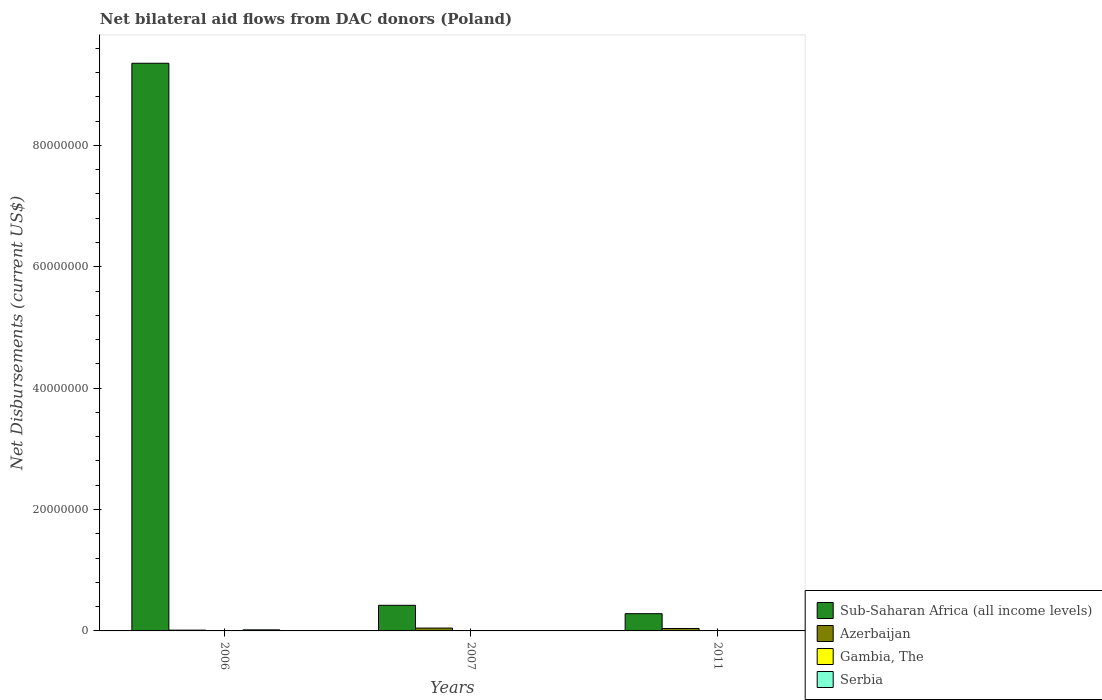How many groups of bars are there?
Your answer should be very brief. 3. How many bars are there on the 3rd tick from the right?
Your answer should be very brief. 4. What is the net bilateral aid flows in Gambia, The in 2007?
Make the answer very short. 2.00e+04. Across all years, what is the maximum net bilateral aid flows in Sub-Saharan Africa (all income levels)?
Keep it short and to the point. 9.35e+07. Across all years, what is the minimum net bilateral aid flows in Gambia, The?
Offer a terse response. 10000. In which year was the net bilateral aid flows in Serbia maximum?
Keep it short and to the point. 2006. What is the difference between the net bilateral aid flows in Gambia, The in 2006 and that in 2011?
Make the answer very short. 2.00e+04. What is the difference between the net bilateral aid flows in Serbia in 2007 and the net bilateral aid flows in Sub-Saharan Africa (all income levels) in 2011?
Your response must be concise. -2.84e+06. What is the average net bilateral aid flows in Sub-Saharan Africa (all income levels) per year?
Your response must be concise. 3.35e+07. In the year 2011, what is the difference between the net bilateral aid flows in Gambia, The and net bilateral aid flows in Sub-Saharan Africa (all income levels)?
Offer a terse response. -2.83e+06. In how many years, is the net bilateral aid flows in Gambia, The greater than 32000000 US$?
Provide a succinct answer. 0. What is the ratio of the net bilateral aid flows in Sub-Saharan Africa (all income levels) in 2006 to that in 2011?
Your answer should be compact. 32.94. What is the difference between the highest and the second highest net bilateral aid flows in Sub-Saharan Africa (all income levels)?
Provide a succinct answer. 8.93e+07. What is the difference between the highest and the lowest net bilateral aid flows in Sub-Saharan Africa (all income levels)?
Offer a terse response. 9.07e+07. Are all the bars in the graph horizontal?
Provide a short and direct response. No. What is the difference between two consecutive major ticks on the Y-axis?
Provide a short and direct response. 2.00e+07. Are the values on the major ticks of Y-axis written in scientific E-notation?
Your response must be concise. No. Does the graph contain any zero values?
Ensure brevity in your answer.  Yes. Where does the legend appear in the graph?
Your response must be concise. Bottom right. How many legend labels are there?
Give a very brief answer. 4. How are the legend labels stacked?
Your answer should be very brief. Vertical. What is the title of the graph?
Your answer should be compact. Net bilateral aid flows from DAC donors (Poland). What is the label or title of the X-axis?
Provide a succinct answer. Years. What is the label or title of the Y-axis?
Offer a very short reply. Net Disbursements (current US$). What is the Net Disbursements (current US$) in Sub-Saharan Africa (all income levels) in 2006?
Your answer should be compact. 9.35e+07. What is the Net Disbursements (current US$) of Azerbaijan in 2006?
Your answer should be compact. 1.30e+05. What is the Net Disbursements (current US$) of Gambia, The in 2006?
Give a very brief answer. 3.00e+04. What is the Net Disbursements (current US$) of Sub-Saharan Africa (all income levels) in 2007?
Keep it short and to the point. 4.22e+06. What is the Net Disbursements (current US$) in Azerbaijan in 2007?
Your response must be concise. 4.70e+05. What is the Net Disbursements (current US$) in Sub-Saharan Africa (all income levels) in 2011?
Your answer should be very brief. 2.84e+06. What is the Net Disbursements (current US$) in Azerbaijan in 2011?
Make the answer very short. 4.00e+05. What is the Net Disbursements (current US$) of Gambia, The in 2011?
Offer a terse response. 10000. What is the Net Disbursements (current US$) in Serbia in 2011?
Provide a short and direct response. 0. Across all years, what is the maximum Net Disbursements (current US$) in Sub-Saharan Africa (all income levels)?
Provide a succinct answer. 9.35e+07. Across all years, what is the maximum Net Disbursements (current US$) in Azerbaijan?
Your answer should be very brief. 4.70e+05. Across all years, what is the maximum Net Disbursements (current US$) in Gambia, The?
Your response must be concise. 3.00e+04. Across all years, what is the maximum Net Disbursements (current US$) in Serbia?
Provide a succinct answer. 1.80e+05. Across all years, what is the minimum Net Disbursements (current US$) in Sub-Saharan Africa (all income levels)?
Ensure brevity in your answer.  2.84e+06. What is the total Net Disbursements (current US$) in Sub-Saharan Africa (all income levels) in the graph?
Ensure brevity in your answer.  1.01e+08. What is the total Net Disbursements (current US$) of Azerbaijan in the graph?
Your answer should be compact. 1.00e+06. What is the total Net Disbursements (current US$) of Gambia, The in the graph?
Provide a succinct answer. 6.00e+04. What is the difference between the Net Disbursements (current US$) of Sub-Saharan Africa (all income levels) in 2006 and that in 2007?
Make the answer very short. 8.93e+07. What is the difference between the Net Disbursements (current US$) of Azerbaijan in 2006 and that in 2007?
Your response must be concise. -3.40e+05. What is the difference between the Net Disbursements (current US$) in Sub-Saharan Africa (all income levels) in 2006 and that in 2011?
Your response must be concise. 9.07e+07. What is the difference between the Net Disbursements (current US$) in Gambia, The in 2006 and that in 2011?
Make the answer very short. 2.00e+04. What is the difference between the Net Disbursements (current US$) in Sub-Saharan Africa (all income levels) in 2007 and that in 2011?
Offer a very short reply. 1.38e+06. What is the difference between the Net Disbursements (current US$) in Sub-Saharan Africa (all income levels) in 2006 and the Net Disbursements (current US$) in Azerbaijan in 2007?
Your answer should be compact. 9.31e+07. What is the difference between the Net Disbursements (current US$) in Sub-Saharan Africa (all income levels) in 2006 and the Net Disbursements (current US$) in Gambia, The in 2007?
Make the answer very short. 9.35e+07. What is the difference between the Net Disbursements (current US$) in Sub-Saharan Africa (all income levels) in 2006 and the Net Disbursements (current US$) in Azerbaijan in 2011?
Offer a very short reply. 9.31e+07. What is the difference between the Net Disbursements (current US$) in Sub-Saharan Africa (all income levels) in 2006 and the Net Disbursements (current US$) in Gambia, The in 2011?
Your answer should be compact. 9.35e+07. What is the difference between the Net Disbursements (current US$) in Sub-Saharan Africa (all income levels) in 2007 and the Net Disbursements (current US$) in Azerbaijan in 2011?
Make the answer very short. 3.82e+06. What is the difference between the Net Disbursements (current US$) in Sub-Saharan Africa (all income levels) in 2007 and the Net Disbursements (current US$) in Gambia, The in 2011?
Provide a short and direct response. 4.21e+06. What is the average Net Disbursements (current US$) in Sub-Saharan Africa (all income levels) per year?
Your answer should be very brief. 3.35e+07. What is the average Net Disbursements (current US$) of Azerbaijan per year?
Offer a very short reply. 3.33e+05. What is the average Net Disbursements (current US$) of Gambia, The per year?
Your response must be concise. 2.00e+04. What is the average Net Disbursements (current US$) of Serbia per year?
Keep it short and to the point. 6.00e+04. In the year 2006, what is the difference between the Net Disbursements (current US$) of Sub-Saharan Africa (all income levels) and Net Disbursements (current US$) of Azerbaijan?
Make the answer very short. 9.34e+07. In the year 2006, what is the difference between the Net Disbursements (current US$) of Sub-Saharan Africa (all income levels) and Net Disbursements (current US$) of Gambia, The?
Give a very brief answer. 9.35e+07. In the year 2006, what is the difference between the Net Disbursements (current US$) of Sub-Saharan Africa (all income levels) and Net Disbursements (current US$) of Serbia?
Your response must be concise. 9.34e+07. In the year 2006, what is the difference between the Net Disbursements (current US$) in Azerbaijan and Net Disbursements (current US$) in Gambia, The?
Offer a very short reply. 1.00e+05. In the year 2006, what is the difference between the Net Disbursements (current US$) of Azerbaijan and Net Disbursements (current US$) of Serbia?
Offer a terse response. -5.00e+04. In the year 2007, what is the difference between the Net Disbursements (current US$) of Sub-Saharan Africa (all income levels) and Net Disbursements (current US$) of Azerbaijan?
Keep it short and to the point. 3.75e+06. In the year 2007, what is the difference between the Net Disbursements (current US$) in Sub-Saharan Africa (all income levels) and Net Disbursements (current US$) in Gambia, The?
Your answer should be compact. 4.20e+06. In the year 2007, what is the difference between the Net Disbursements (current US$) in Azerbaijan and Net Disbursements (current US$) in Gambia, The?
Give a very brief answer. 4.50e+05. In the year 2011, what is the difference between the Net Disbursements (current US$) in Sub-Saharan Africa (all income levels) and Net Disbursements (current US$) in Azerbaijan?
Keep it short and to the point. 2.44e+06. In the year 2011, what is the difference between the Net Disbursements (current US$) of Sub-Saharan Africa (all income levels) and Net Disbursements (current US$) of Gambia, The?
Provide a succinct answer. 2.83e+06. In the year 2011, what is the difference between the Net Disbursements (current US$) of Azerbaijan and Net Disbursements (current US$) of Gambia, The?
Your answer should be compact. 3.90e+05. What is the ratio of the Net Disbursements (current US$) in Sub-Saharan Africa (all income levels) in 2006 to that in 2007?
Your answer should be compact. 22.17. What is the ratio of the Net Disbursements (current US$) of Azerbaijan in 2006 to that in 2007?
Provide a short and direct response. 0.28. What is the ratio of the Net Disbursements (current US$) of Gambia, The in 2006 to that in 2007?
Your answer should be very brief. 1.5. What is the ratio of the Net Disbursements (current US$) in Sub-Saharan Africa (all income levels) in 2006 to that in 2011?
Your response must be concise. 32.94. What is the ratio of the Net Disbursements (current US$) of Azerbaijan in 2006 to that in 2011?
Make the answer very short. 0.33. What is the ratio of the Net Disbursements (current US$) in Gambia, The in 2006 to that in 2011?
Provide a short and direct response. 3. What is the ratio of the Net Disbursements (current US$) in Sub-Saharan Africa (all income levels) in 2007 to that in 2011?
Make the answer very short. 1.49. What is the ratio of the Net Disbursements (current US$) in Azerbaijan in 2007 to that in 2011?
Make the answer very short. 1.18. What is the difference between the highest and the second highest Net Disbursements (current US$) of Sub-Saharan Africa (all income levels)?
Give a very brief answer. 8.93e+07. What is the difference between the highest and the second highest Net Disbursements (current US$) of Azerbaijan?
Your answer should be very brief. 7.00e+04. What is the difference between the highest and the lowest Net Disbursements (current US$) of Sub-Saharan Africa (all income levels)?
Your answer should be very brief. 9.07e+07. What is the difference between the highest and the lowest Net Disbursements (current US$) of Serbia?
Keep it short and to the point. 1.80e+05. 